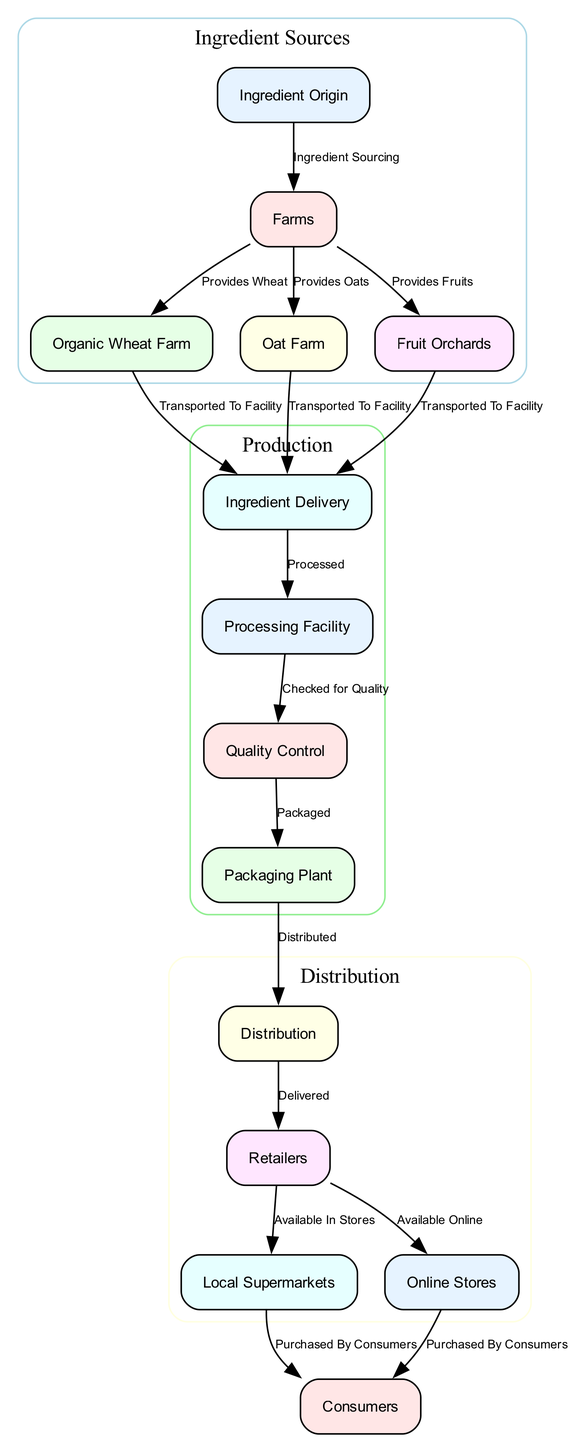What is the first node in the diagram? The first node in the diagram is "Ingredient Origin." This is indicated by the node that is positioned at the top of the diagram, serving as the starting point for the food chain process.
Answer: Ingredient Origin How many farms are represented in the diagram? The diagram lists three types of farms: Organic Wheat Farm, Oat Farm, and Fruit Orchards. Therefore, there are three farms depicted.
Answer: 3 What is delivered to the processing facility? The processing facility receives transport from the ingredient sources, which include wheat, oats, and fruits. Hence, the answer is "wheat, oats, fruits."
Answer: Wheat, oats, fruits Which node directly follows the quality control node? The node that directly follows "Quality Control" is "Packaging Plant," as indicated by the directed edge in the diagram connecting them in that order.
Answer: Packaging Plant What function does the processing facility serve? The processing facility's function is to process the ingredients received from the farms. This is clearly labeled in the diagram as part of the food chain sequence.
Answer: Processed How many nodes are in the distribution section? The distribution section, as identified by the clustered group labeled, includes three nodes: Distribution, Retailers, and Local Supermarkets, and Online Stores. Therefore, there are four nodes in total.
Answer: 4 What type of quality check is performed before packaging? The check performed before packaging is "Checked for Quality," which is explicitly stated as the action taken after processing and before the packaging step.
Answer: Checked for Quality Where do consumers purchase the teething biscuits? Consumers purchase the teething biscuits either from "Local Supermarkets" or "Online Stores," according to the paths leading to the consumers' node.
Answer: Local Supermarkets, Online Stores What is the last step of the food chain? The last step in the food chain is "Purchased By Consumers," indicating that the process concludes when the consumers acquire the teething biscuits.
Answer: Purchased By Consumers 